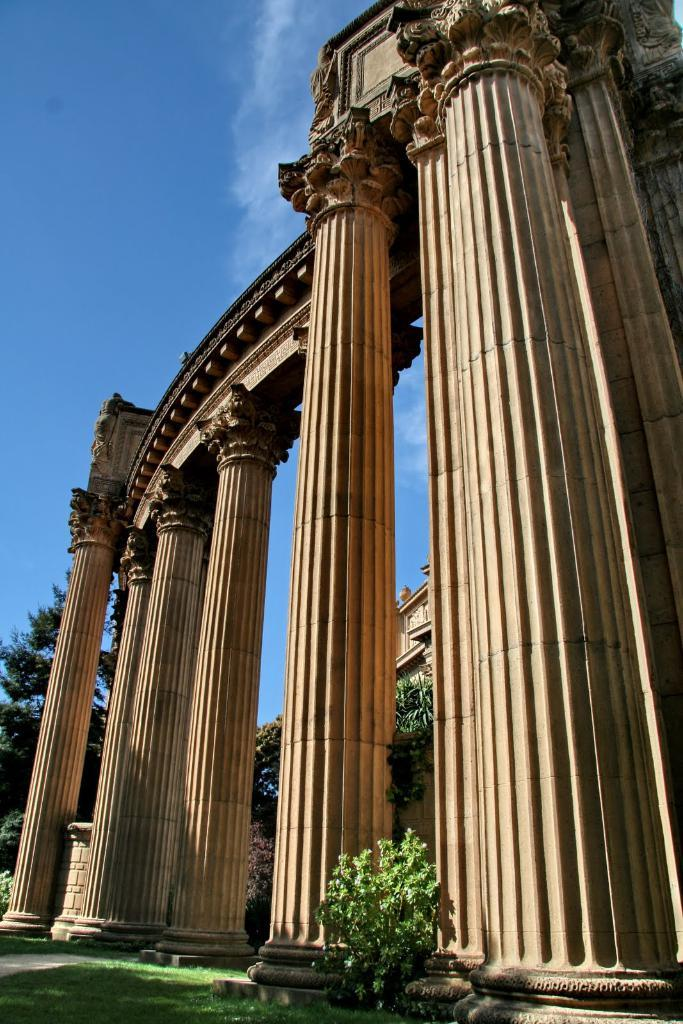What type of structure is visible in the image? There is a building in the image. What architectural features can be seen on the building? There are pillars visible on the building. What type of vegetation is present at the bottom of the image? There is a plant and grass at the bottom of the image. What can be seen in the background of the image? There are trees and the sky visible in the background of the image. What type of bun is being held by the mom in the image? There is no mom or bun present in the image. 